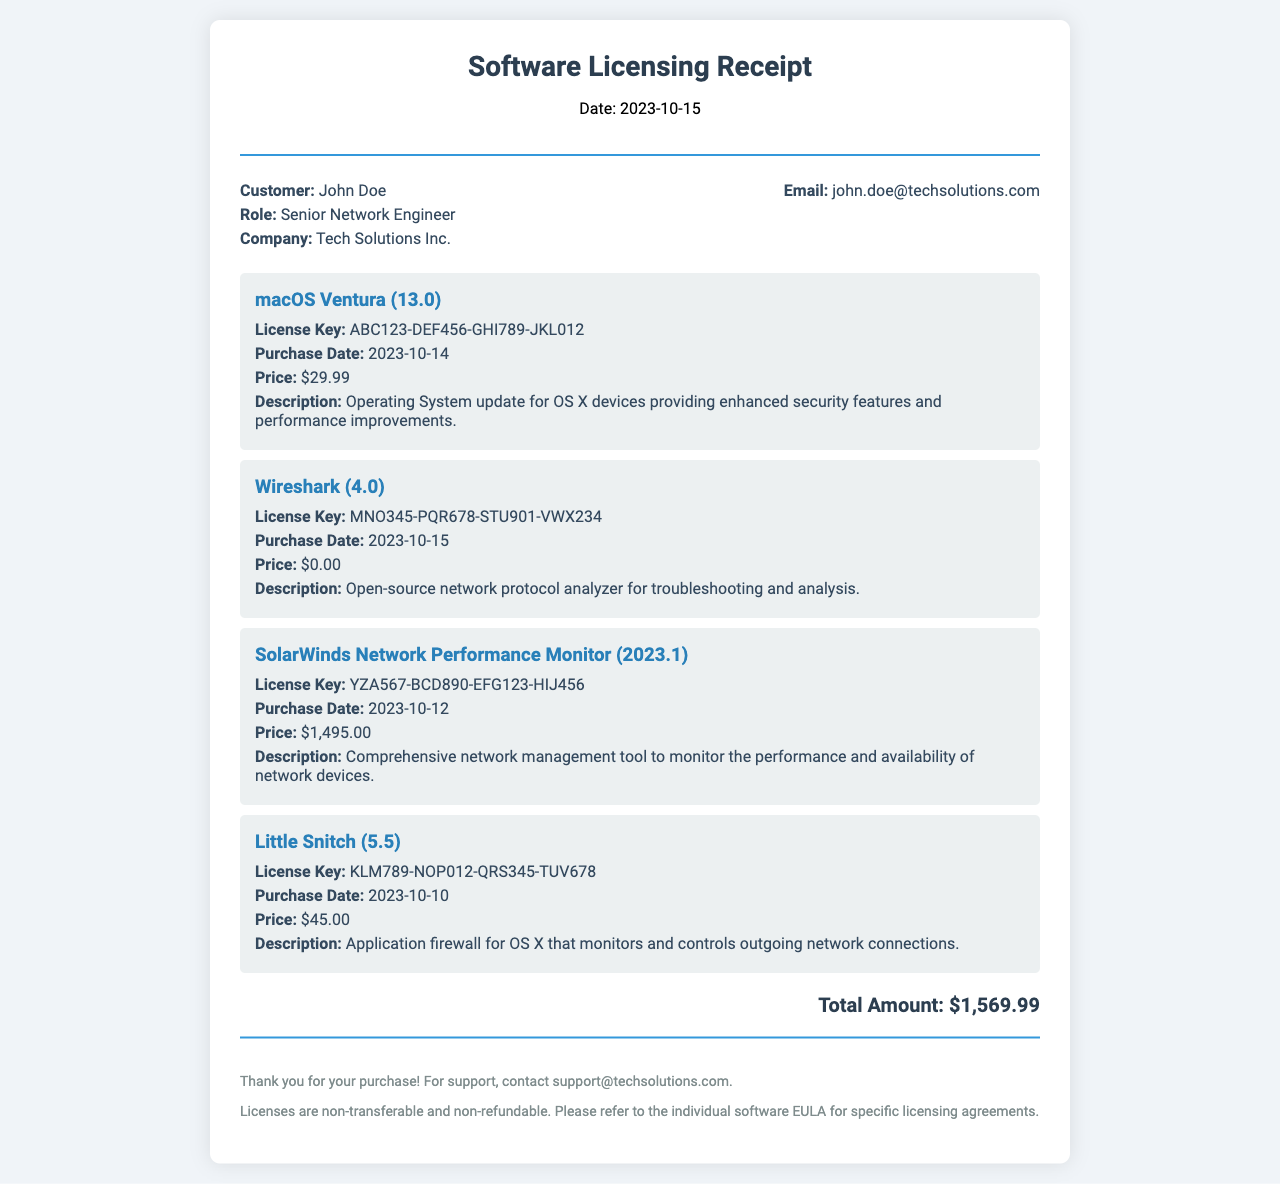What is the total amount? The total amount is stated at the bottom of the receipt, which sums up the prices of all items listed.
Answer: $1,569.99 Who is the customer? The receipt clearly displays the customer's name at the top under customer information.
Answer: John Doe What company does the customer work for? The company name is listed alongside the customer's details in the document.
Answer: Tech Solutions Inc What is the license key for macOS Ventura? The license key is provided in the description of the respective item in the receipt.
Answer: ABC123-DEF456-GHI789-JKL012 What is the purchase date of SolarWinds Network Performance Monitor? The purchase date is listed under the item details for SolarWinds Network Performance Monitor.
Answer: 2023-10-12 Which software has a price of $0.00? The price of each item is provided, and the one that costs $0.00 needs to be identified.
Answer: Wireshark What type of tool is Little Snitch? The description under Little Snitch indicates its function in the context of network security.
Answer: Application firewall How many items are listed in the receipt? The total number of items can be counted from the itemized section of the receipt.
Answer: 4 When was the receipt issued? The date of the receipt is prominently displayed at the top of the document.
Answer: 2023-10-15 